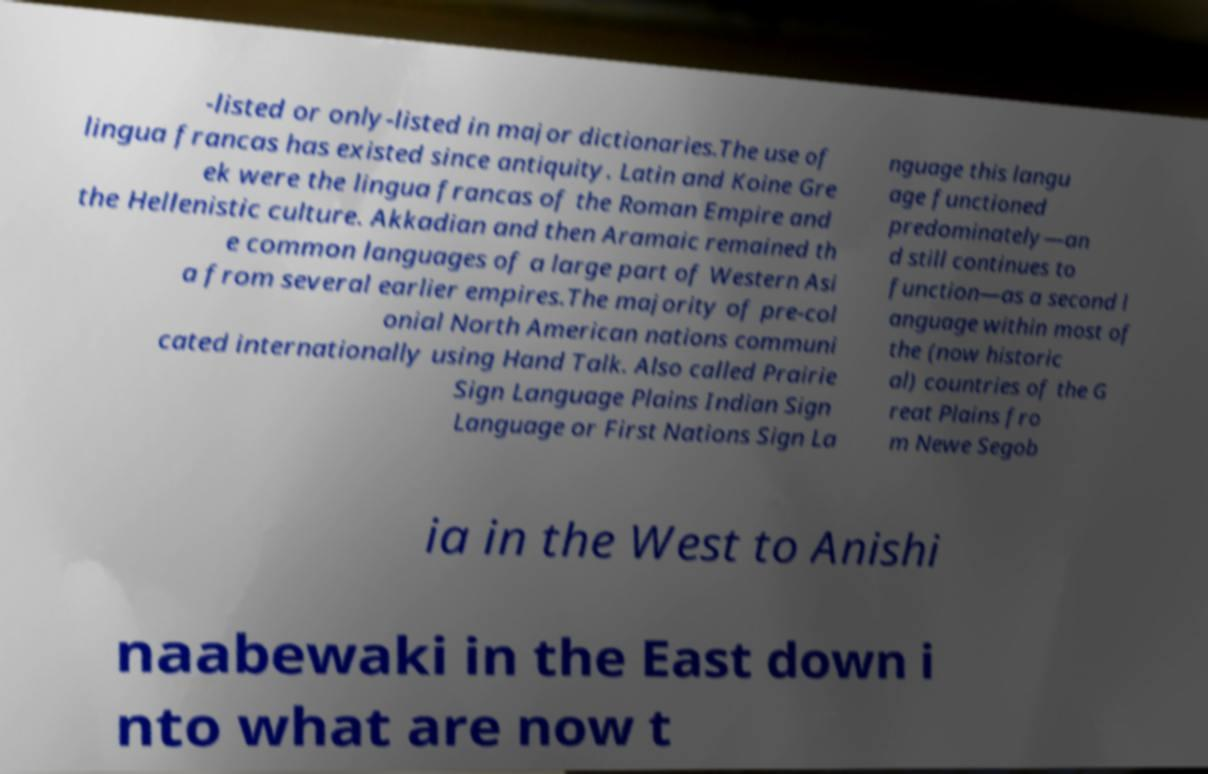Please read and relay the text visible in this image. What does it say? -listed or only-listed in major dictionaries.The use of lingua francas has existed since antiquity. Latin and Koine Gre ek were the lingua francas of the Roman Empire and the Hellenistic culture. Akkadian and then Aramaic remained th e common languages of a large part of Western Asi a from several earlier empires.The majority of pre-col onial North American nations communi cated internationally using Hand Talk. Also called Prairie Sign Language Plains Indian Sign Language or First Nations Sign La nguage this langu age functioned predominately—an d still continues to function—as a second l anguage within most of the (now historic al) countries of the G reat Plains fro m Newe Segob ia in the West to Anishi naabewaki in the East down i nto what are now t 